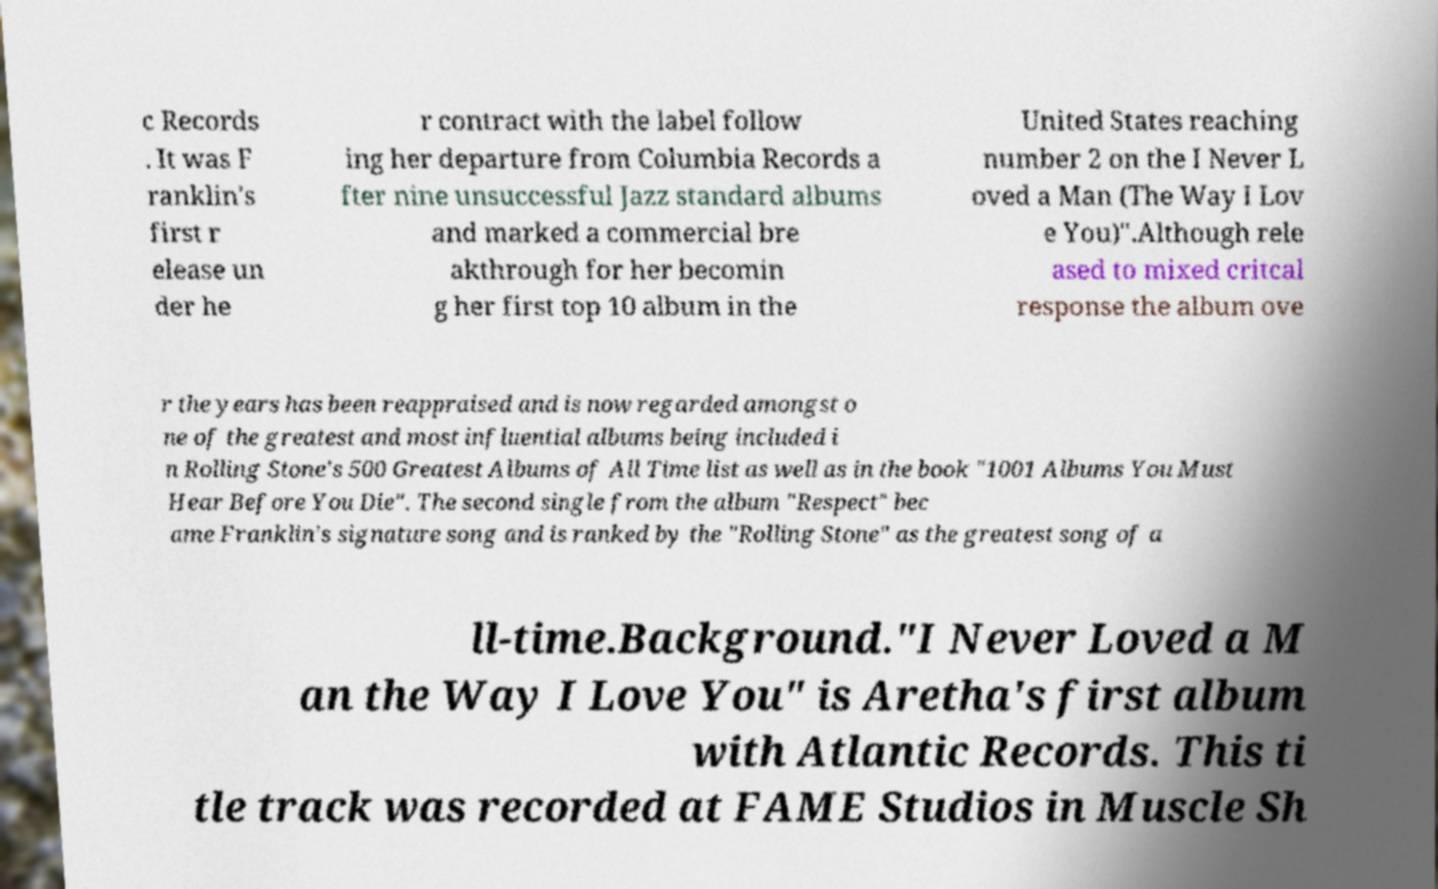There's text embedded in this image that I need extracted. Can you transcribe it verbatim? c Records . It was F ranklin's first r elease un der he r contract with the label follow ing her departure from Columbia Records a fter nine unsuccessful Jazz standard albums and marked a commercial bre akthrough for her becomin g her first top 10 album in the United States reaching number 2 on the I Never L oved a Man (The Way I Lov e You)".Although rele ased to mixed critcal response the album ove r the years has been reappraised and is now regarded amongst o ne of the greatest and most influential albums being included i n Rolling Stone's 500 Greatest Albums of All Time list as well as in the book "1001 Albums You Must Hear Before You Die". The second single from the album "Respect" bec ame Franklin's signature song and is ranked by the "Rolling Stone" as the greatest song of a ll-time.Background."I Never Loved a M an the Way I Love You" is Aretha's first album with Atlantic Records. This ti tle track was recorded at FAME Studios in Muscle Sh 